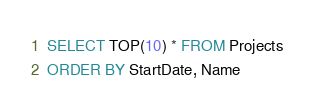<code> <loc_0><loc_0><loc_500><loc_500><_SQL_>SELECT TOP(10) * FROM Projects
ORDER BY StartDate, Name</code> 